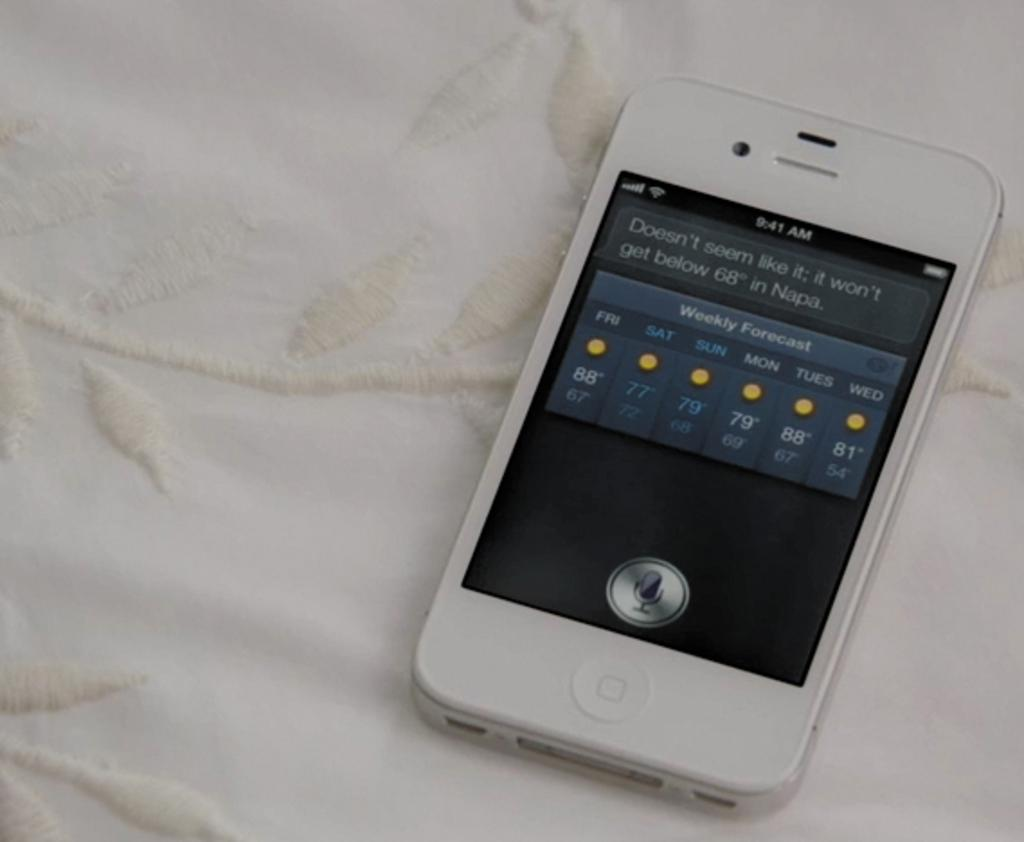<image>
Present a compact description of the photo's key features. Phone screen that currently shows the time at 9:41 AM. 